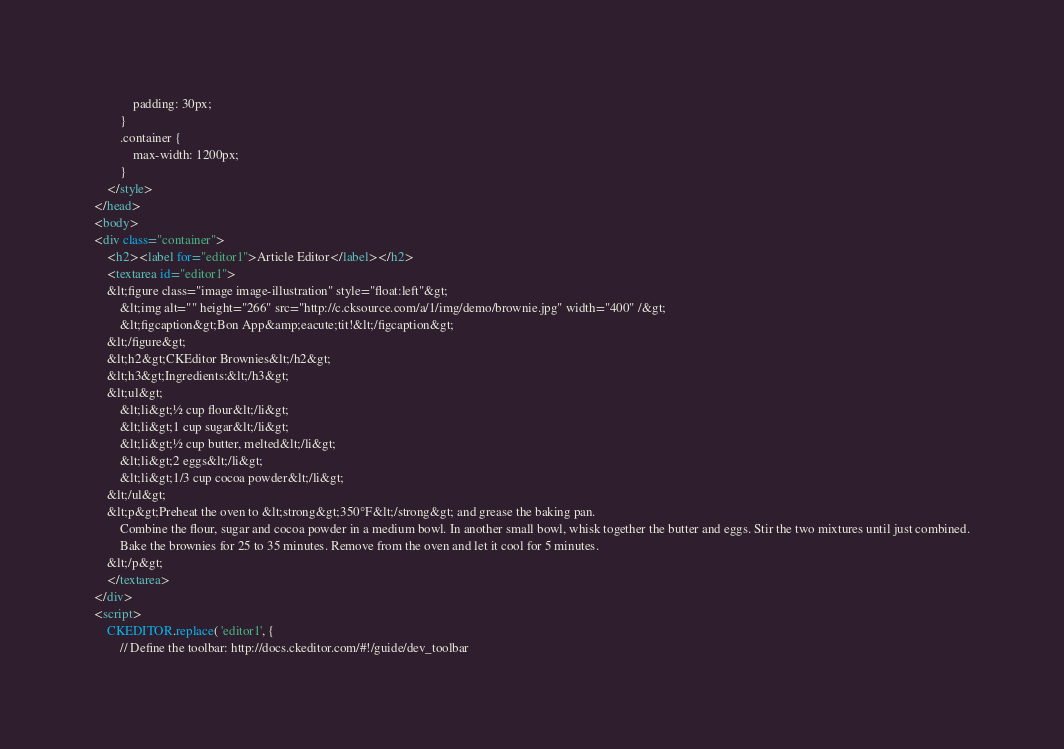Convert code to text. <code><loc_0><loc_0><loc_500><loc_500><_HTML_>			padding: 30px;
		}
		.container {
			max-width: 1200px;
		}
	</style>
</head>
<body>
<div class="container">
	<h2><label for="editor1">Article Editor</label></h2>
	<textarea id="editor1">
	&lt;figure class="image image-illustration" style="float:left"&gt;
		&lt;img alt="" height="266" src="http://c.cksource.com/a/1/img/demo/brownie.jpg" width="400" /&gt;
		&lt;figcaption&gt;Bon App&amp;eacute;tit!&lt;/figcaption&gt;
	&lt;/figure&gt;
	&lt;h2&gt;CKEditor Brownies&lt;/h2&gt;
	&lt;h3&gt;Ingredients:&lt;/h3&gt;
	&lt;ul&gt;
		&lt;li&gt;½ cup flour&lt;/li&gt;
		&lt;li&gt;1 cup sugar&lt;/li&gt;
		&lt;li&gt;½ cup butter, melted&lt;/li&gt;
		&lt;li&gt;2 eggs&lt;/li&gt;
		&lt;li&gt;1/3 cup cocoa powder&lt;/li&gt;
	&lt;/ul&gt;
	&lt;p&gt;Preheat the oven to &lt;strong&gt;350°F&lt;/strong&gt; and grease the baking pan.
		Combine the flour, sugar and cocoa powder in a medium bowl. In another small bowl, whisk together the butter and eggs. Stir the two mixtures until just combined.
		Bake the brownies for 25 to 35 minutes. Remove from the oven and let it cool for 5 minutes.
	&lt;/p&gt;
	</textarea>
</div>
<script>
	CKEDITOR.replace( 'editor1', {
		// Define the toolbar: http://docs.ckeditor.com/#!/guide/dev_toolbar</code> 